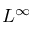<formula> <loc_0><loc_0><loc_500><loc_500>L ^ { \infty }</formula> 